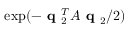<formula> <loc_0><loc_0><loc_500><loc_500>\exp ( - q _ { 2 } ^ { T } A q _ { 2 } / 2 )</formula> 